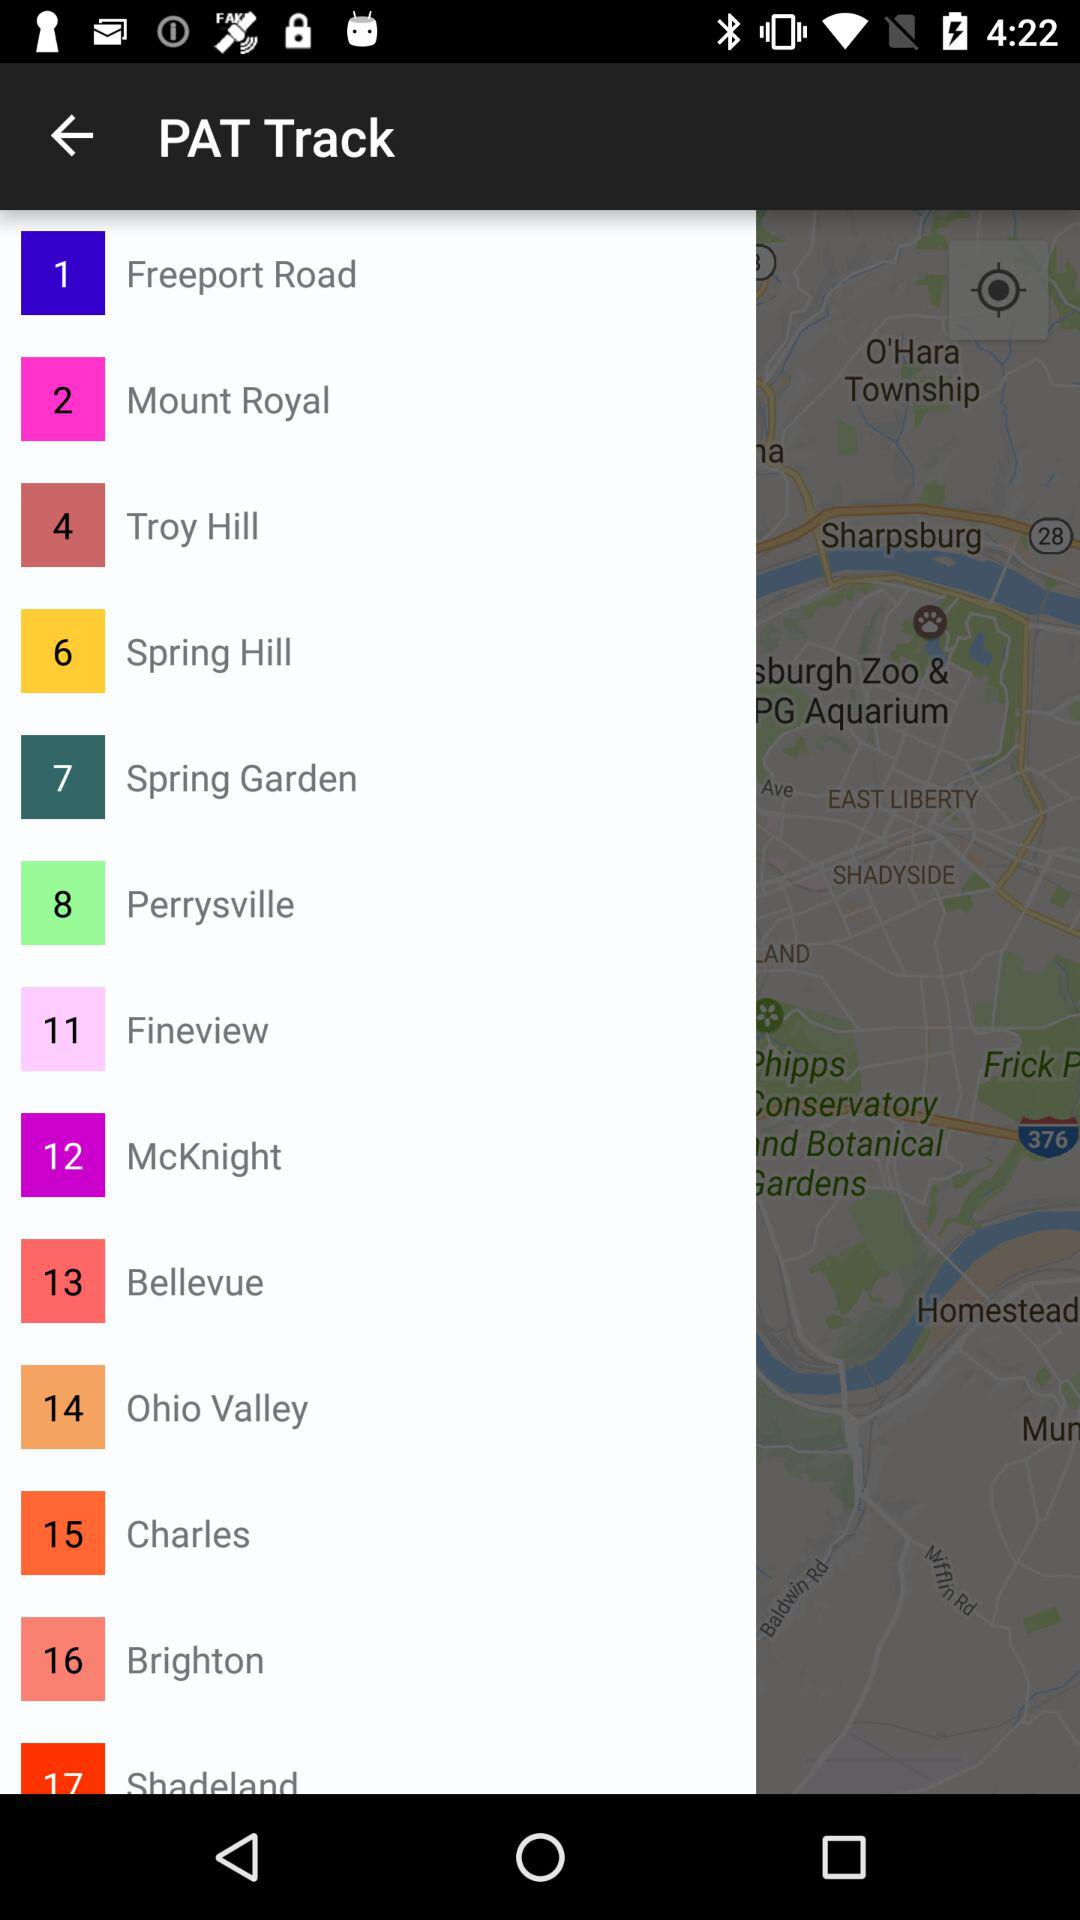What is the application name? The application name is "PAT Track". 